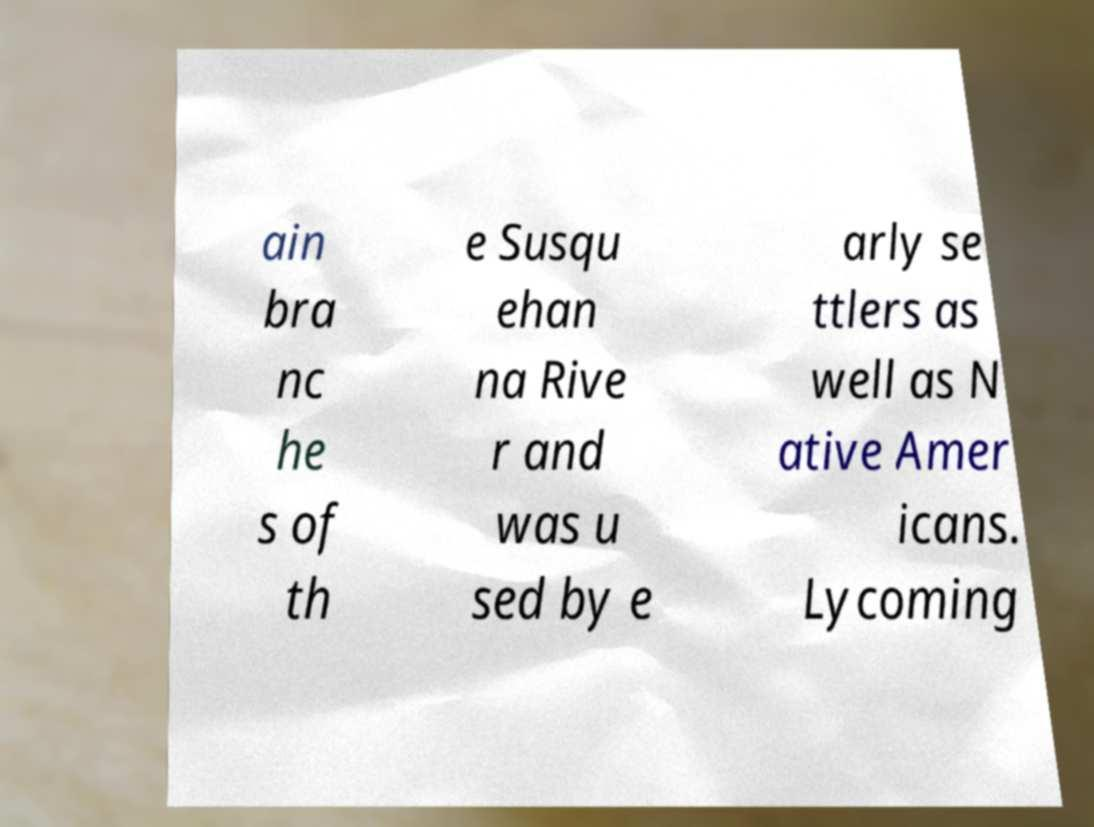What messages or text are displayed in this image? I need them in a readable, typed format. ain bra nc he s of th e Susqu ehan na Rive r and was u sed by e arly se ttlers as well as N ative Amer icans. Lycoming 